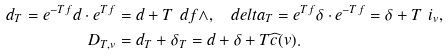Convert formula to latex. <formula><loc_0><loc_0><loc_500><loc_500>d _ { T } = e ^ { - T f } d \cdot e ^ { T f } & = d + T \ d f \wedge , \quad d e l t a _ { T } = e ^ { T f } \delta \cdot e ^ { - T f } = \delta + T \ i _ { v } , \\ D _ { T , v } & = d _ { T } + \delta _ { T } = d + \delta + T \widehat { c } ( v ) .</formula> 